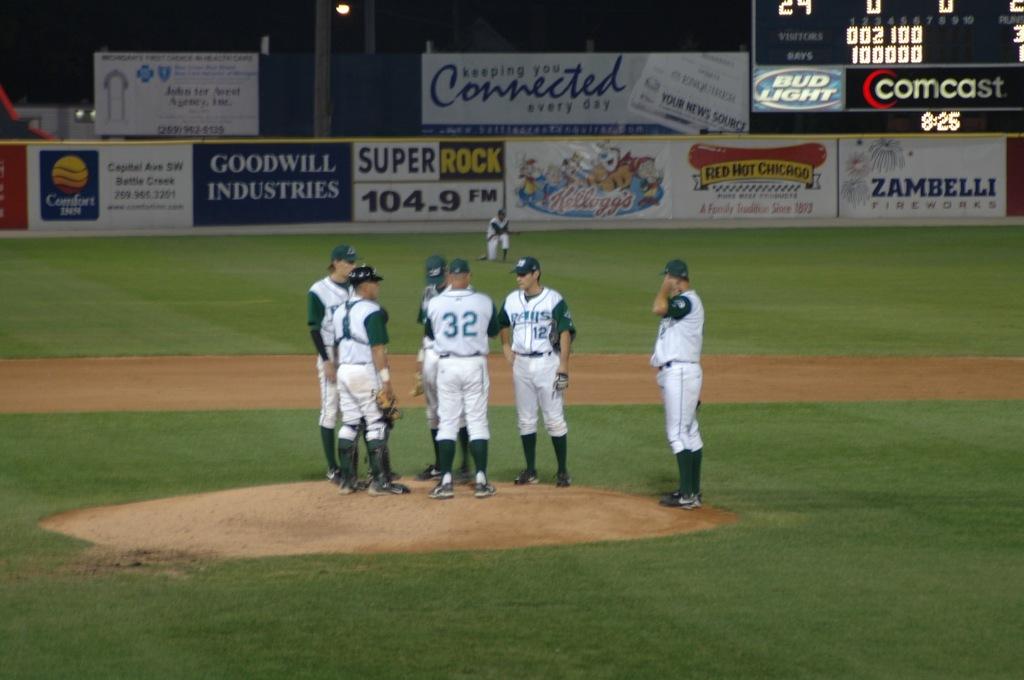What radio station is super rock?
Make the answer very short. 104.9 fm. Which inn is being advertised?
Make the answer very short. Comfort. 